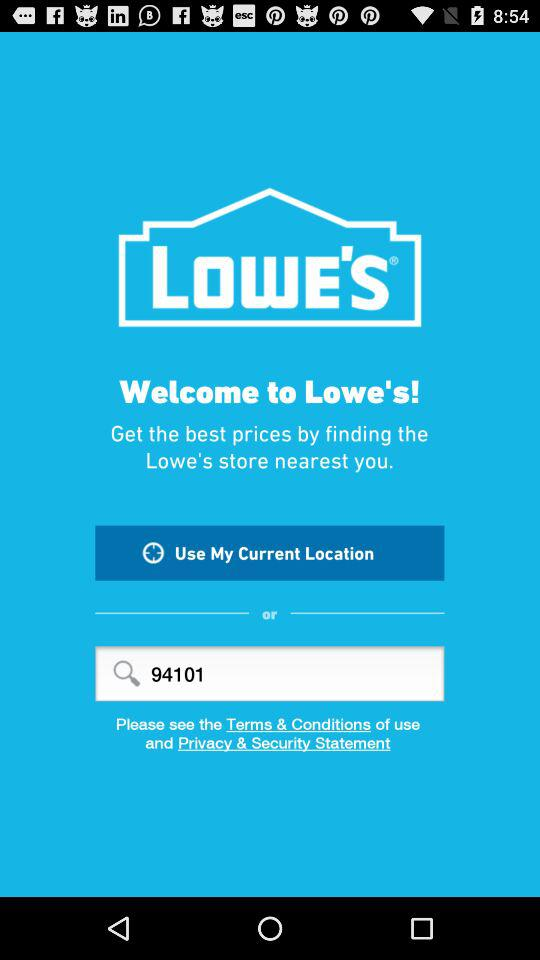What is the app name? The app name is "LOWE'S". 